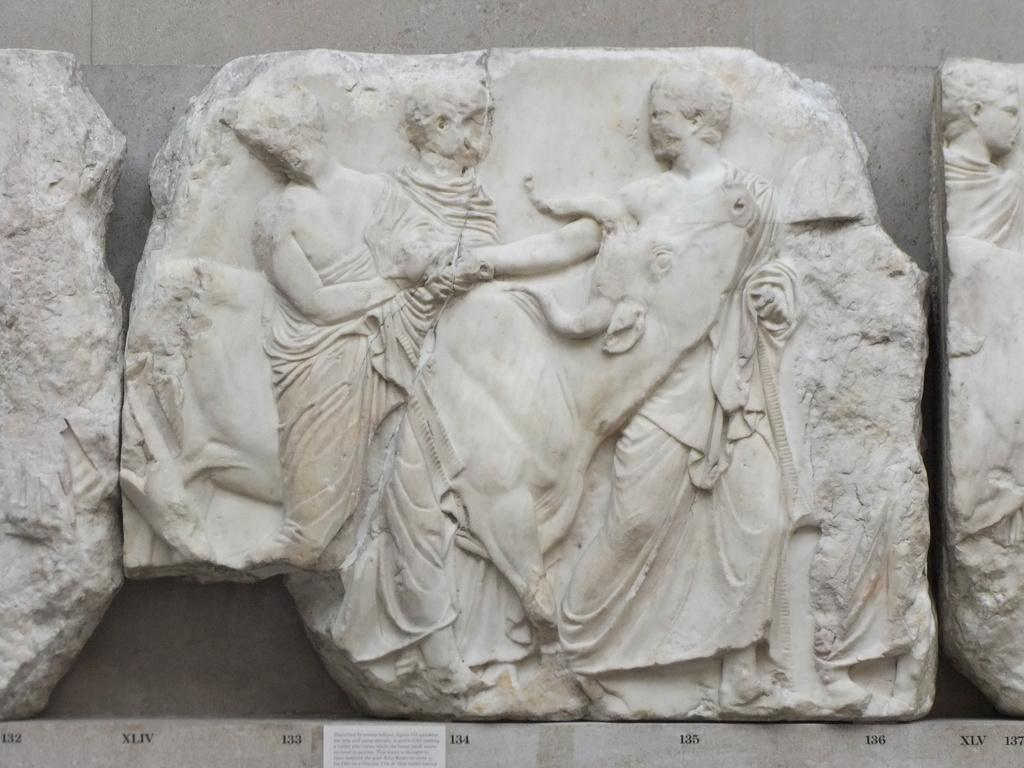What is depicted on the stone in the image? There is a carving on a white color stone in the image. How is the stone positioned in the image? The stone is placed in the image. What can be seen in the background of the image? There is a wall in the background of the image. What type of doll is sitting on the grandmother's lap in the image? There is no doll or grandmother present in the image; it features a stone with a carving and a wall in the background. 